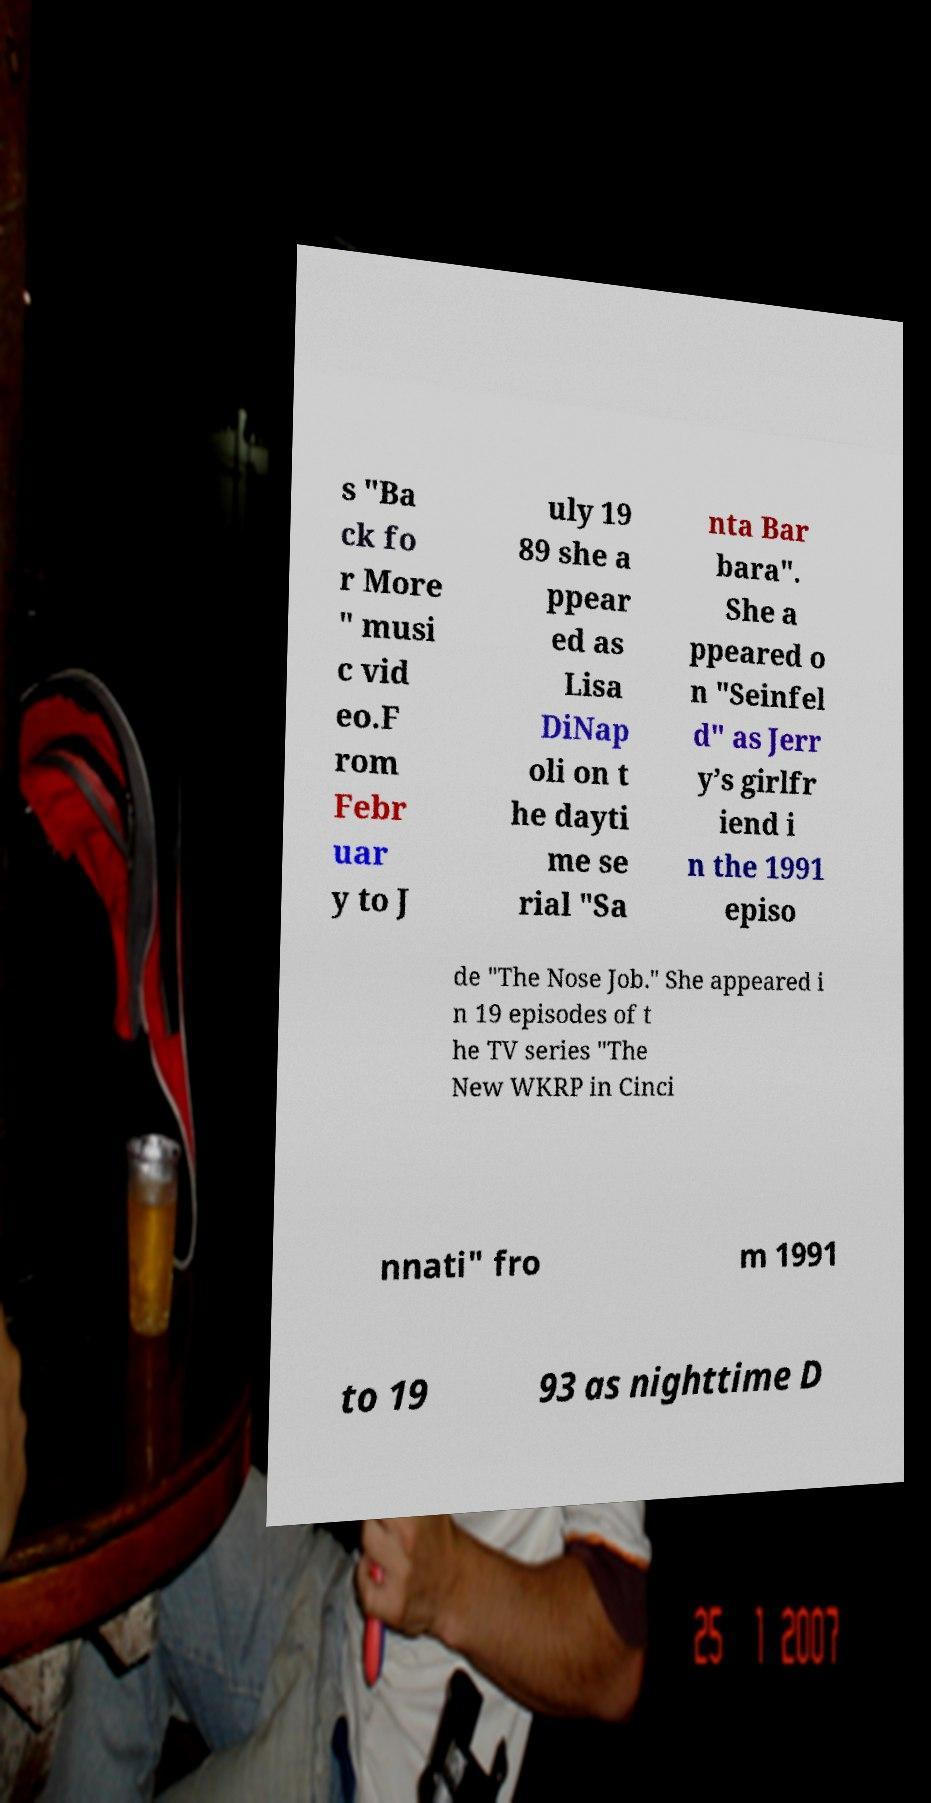Could you assist in decoding the text presented in this image and type it out clearly? s "Ba ck fo r More " musi c vid eo.F rom Febr uar y to J uly 19 89 she a ppear ed as Lisa DiNap oli on t he dayti me se rial "Sa nta Bar bara". She a ppeared o n "Seinfel d" as Jerr y’s girlfr iend i n the 1991 episo de "The Nose Job." She appeared i n 19 episodes of t he TV series "The New WKRP in Cinci nnati" fro m 1991 to 19 93 as nighttime D 